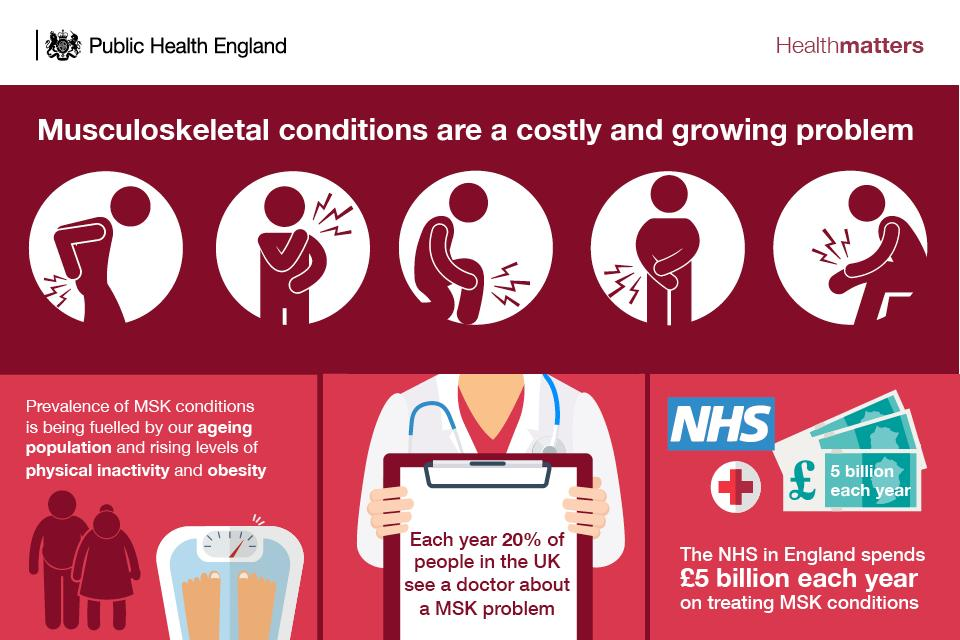Indicate a few pertinent items in this graphic. There are three images of money in the infographic. 